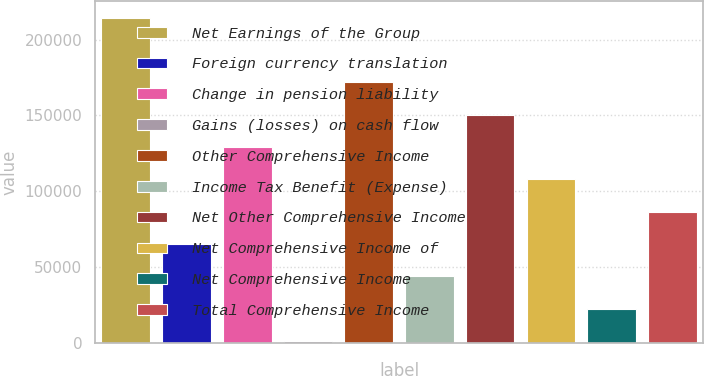Convert chart. <chart><loc_0><loc_0><loc_500><loc_500><bar_chart><fcel>Net Earnings of the Group<fcel>Foreign currency translation<fcel>Change in pension liability<fcel>Gains (losses) on cash flow<fcel>Other Comprehensive Income<fcel>Income Tax Benefit (Expense)<fcel>Net Other Comprehensive Income<fcel>Net Comprehensive Income of<fcel>Net Comprehensive Income<fcel>Total Comprehensive Income<nl><fcel>214515<fcel>65336.6<fcel>129270<fcel>1403<fcel>171893<fcel>44025.4<fcel>150581<fcel>107959<fcel>22714.2<fcel>86647.8<nl></chart> 